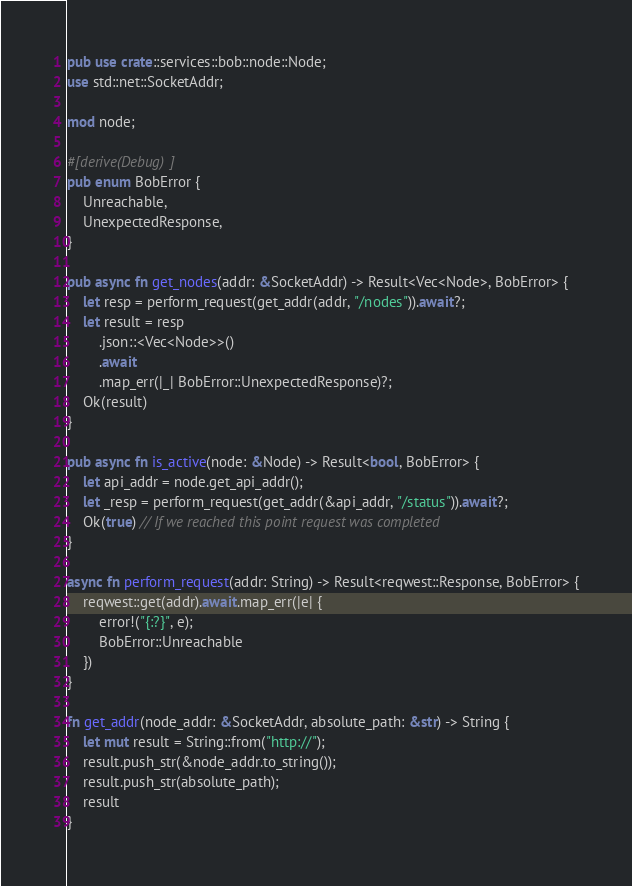Convert code to text. <code><loc_0><loc_0><loc_500><loc_500><_Rust_>pub use crate::services::bob::node::Node;
use std::net::SocketAddr;

mod node;

#[derive(Debug)]
pub enum BobError {
    Unreachable,
    UnexpectedResponse,
}

pub async fn get_nodes(addr: &SocketAddr) -> Result<Vec<Node>, BobError> {
    let resp = perform_request(get_addr(addr, "/nodes")).await?;
    let result = resp
        .json::<Vec<Node>>()
        .await
        .map_err(|_| BobError::UnexpectedResponse)?;
    Ok(result)
}

pub async fn is_active(node: &Node) -> Result<bool, BobError> {
    let api_addr = node.get_api_addr();
    let _resp = perform_request(get_addr(&api_addr, "/status")).await?;
    Ok(true) // If we reached this point request was completed
}

async fn perform_request(addr: String) -> Result<reqwest::Response, BobError> {
    reqwest::get(addr).await.map_err(|e| {
        error!("{:?}", e);
        BobError::Unreachable
    })
}

fn get_addr(node_addr: &SocketAddr, absolute_path: &str) -> String {
    let mut result = String::from("http://");
    result.push_str(&node_addr.to_string());
    result.push_str(absolute_path);
    result
}
</code> 